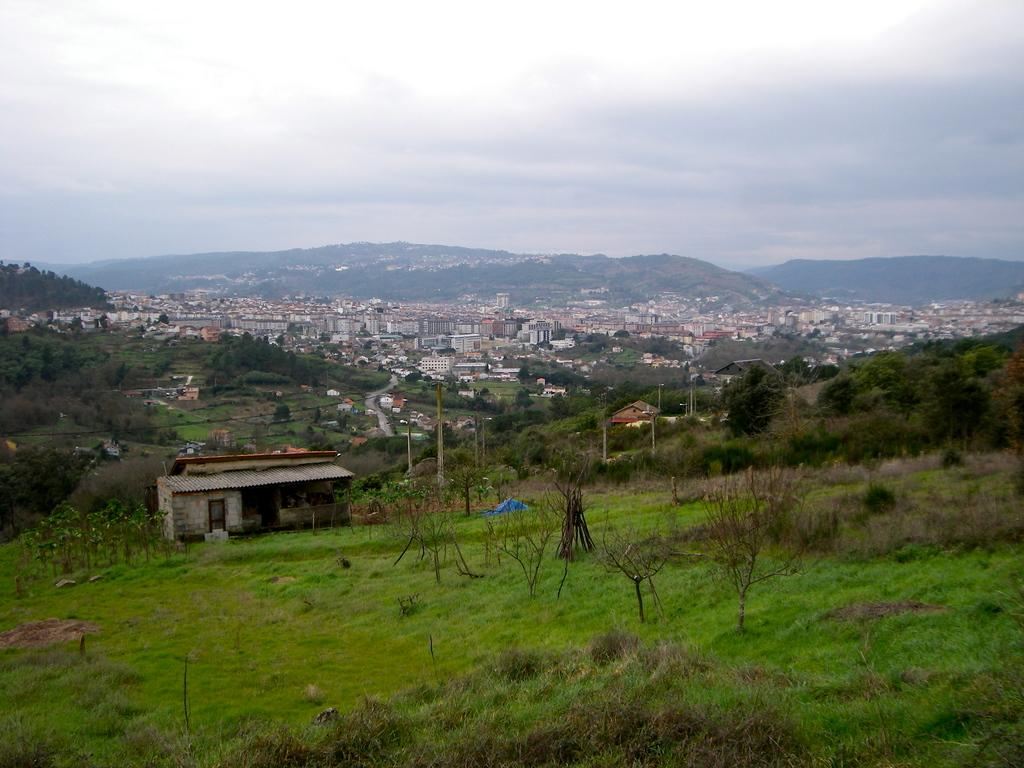What type of landscape is depicted in the image? The image is taken from a hilly area. What structures can be seen in the image? There are many buildings in the image. What type of vegetation is visible in the image? There is grass and trees visible in the image. What is visible at the top of the image? The sky is visible at the top of the image. Can you see any waves crashing on the shore in the image? There are no waves or shore visible in the image; it depicts a hilly area with buildings, grass, trees, and the sky. 